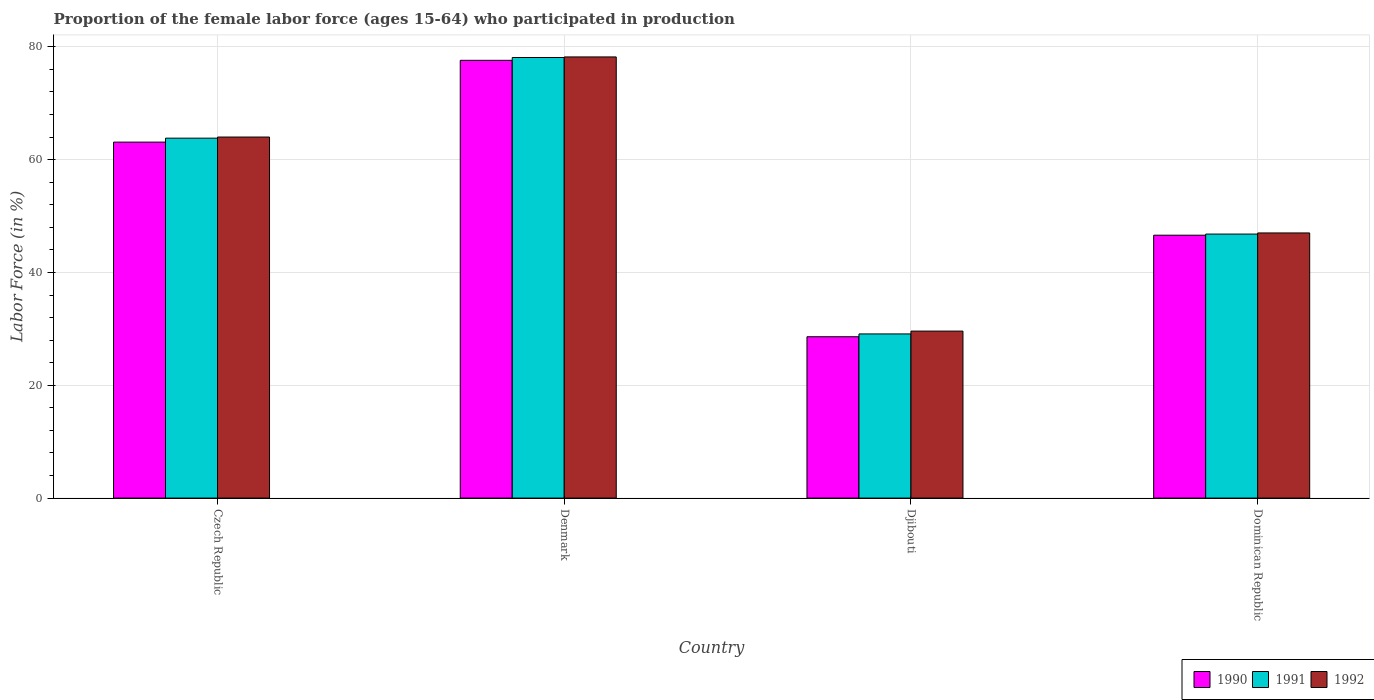How many groups of bars are there?
Keep it short and to the point. 4. How many bars are there on the 4th tick from the right?
Make the answer very short. 3. What is the label of the 4th group of bars from the left?
Provide a succinct answer. Dominican Republic. What is the proportion of the female labor force who participated in production in 1990 in Djibouti?
Provide a short and direct response. 28.6. Across all countries, what is the maximum proportion of the female labor force who participated in production in 1990?
Offer a terse response. 77.6. Across all countries, what is the minimum proportion of the female labor force who participated in production in 1992?
Provide a succinct answer. 29.6. In which country was the proportion of the female labor force who participated in production in 1990 minimum?
Your response must be concise. Djibouti. What is the total proportion of the female labor force who participated in production in 1991 in the graph?
Your answer should be very brief. 217.8. What is the difference between the proportion of the female labor force who participated in production in 1990 in Czech Republic and that in Denmark?
Give a very brief answer. -14.5. What is the difference between the proportion of the female labor force who participated in production in 1991 in Dominican Republic and the proportion of the female labor force who participated in production in 1990 in Czech Republic?
Your answer should be very brief. -16.3. What is the average proportion of the female labor force who participated in production in 1990 per country?
Offer a terse response. 53.97. What is the ratio of the proportion of the female labor force who participated in production in 1991 in Djibouti to that in Dominican Republic?
Keep it short and to the point. 0.62. Is the proportion of the female labor force who participated in production in 1990 in Czech Republic less than that in Denmark?
Your answer should be compact. Yes. What is the difference between the highest and the second highest proportion of the female labor force who participated in production in 1991?
Offer a very short reply. -31.3. What is the difference between the highest and the lowest proportion of the female labor force who participated in production in 1992?
Your answer should be compact. 48.6. What does the 2nd bar from the right in Djibouti represents?
Ensure brevity in your answer.  1991. Is it the case that in every country, the sum of the proportion of the female labor force who participated in production in 1990 and proportion of the female labor force who participated in production in 1992 is greater than the proportion of the female labor force who participated in production in 1991?
Make the answer very short. Yes. How many countries are there in the graph?
Make the answer very short. 4. What is the difference between two consecutive major ticks on the Y-axis?
Your answer should be very brief. 20. Does the graph contain any zero values?
Give a very brief answer. No. Does the graph contain grids?
Give a very brief answer. Yes. How many legend labels are there?
Your answer should be very brief. 3. What is the title of the graph?
Give a very brief answer. Proportion of the female labor force (ages 15-64) who participated in production. Does "1981" appear as one of the legend labels in the graph?
Your answer should be compact. No. What is the Labor Force (in %) in 1990 in Czech Republic?
Your answer should be very brief. 63.1. What is the Labor Force (in %) in 1991 in Czech Republic?
Your answer should be compact. 63.8. What is the Labor Force (in %) of 1992 in Czech Republic?
Your response must be concise. 64. What is the Labor Force (in %) of 1990 in Denmark?
Keep it short and to the point. 77.6. What is the Labor Force (in %) of 1991 in Denmark?
Offer a very short reply. 78.1. What is the Labor Force (in %) in 1992 in Denmark?
Your answer should be compact. 78.2. What is the Labor Force (in %) of 1990 in Djibouti?
Offer a very short reply. 28.6. What is the Labor Force (in %) in 1991 in Djibouti?
Give a very brief answer. 29.1. What is the Labor Force (in %) of 1992 in Djibouti?
Your response must be concise. 29.6. What is the Labor Force (in %) in 1990 in Dominican Republic?
Provide a succinct answer. 46.6. What is the Labor Force (in %) in 1991 in Dominican Republic?
Provide a short and direct response. 46.8. Across all countries, what is the maximum Labor Force (in %) of 1990?
Your answer should be very brief. 77.6. Across all countries, what is the maximum Labor Force (in %) of 1991?
Offer a terse response. 78.1. Across all countries, what is the maximum Labor Force (in %) of 1992?
Offer a terse response. 78.2. Across all countries, what is the minimum Labor Force (in %) of 1990?
Make the answer very short. 28.6. Across all countries, what is the minimum Labor Force (in %) of 1991?
Keep it short and to the point. 29.1. Across all countries, what is the minimum Labor Force (in %) of 1992?
Give a very brief answer. 29.6. What is the total Labor Force (in %) of 1990 in the graph?
Offer a very short reply. 215.9. What is the total Labor Force (in %) of 1991 in the graph?
Your answer should be compact. 217.8. What is the total Labor Force (in %) in 1992 in the graph?
Keep it short and to the point. 218.8. What is the difference between the Labor Force (in %) of 1991 in Czech Republic and that in Denmark?
Provide a succinct answer. -14.3. What is the difference between the Labor Force (in %) in 1990 in Czech Republic and that in Djibouti?
Make the answer very short. 34.5. What is the difference between the Labor Force (in %) of 1991 in Czech Republic and that in Djibouti?
Your response must be concise. 34.7. What is the difference between the Labor Force (in %) of 1992 in Czech Republic and that in Djibouti?
Provide a succinct answer. 34.4. What is the difference between the Labor Force (in %) in 1991 in Denmark and that in Djibouti?
Keep it short and to the point. 49. What is the difference between the Labor Force (in %) in 1992 in Denmark and that in Djibouti?
Your answer should be compact. 48.6. What is the difference between the Labor Force (in %) of 1990 in Denmark and that in Dominican Republic?
Provide a succinct answer. 31. What is the difference between the Labor Force (in %) in 1991 in Denmark and that in Dominican Republic?
Offer a terse response. 31.3. What is the difference between the Labor Force (in %) in 1992 in Denmark and that in Dominican Republic?
Provide a succinct answer. 31.2. What is the difference between the Labor Force (in %) in 1991 in Djibouti and that in Dominican Republic?
Keep it short and to the point. -17.7. What is the difference between the Labor Force (in %) of 1992 in Djibouti and that in Dominican Republic?
Offer a terse response. -17.4. What is the difference between the Labor Force (in %) in 1990 in Czech Republic and the Labor Force (in %) in 1992 in Denmark?
Your answer should be very brief. -15.1. What is the difference between the Labor Force (in %) in 1991 in Czech Republic and the Labor Force (in %) in 1992 in Denmark?
Provide a succinct answer. -14.4. What is the difference between the Labor Force (in %) in 1990 in Czech Republic and the Labor Force (in %) in 1991 in Djibouti?
Your answer should be very brief. 34. What is the difference between the Labor Force (in %) in 1990 in Czech Republic and the Labor Force (in %) in 1992 in Djibouti?
Give a very brief answer. 33.5. What is the difference between the Labor Force (in %) of 1991 in Czech Republic and the Labor Force (in %) of 1992 in Djibouti?
Your answer should be very brief. 34.2. What is the difference between the Labor Force (in %) in 1990 in Czech Republic and the Labor Force (in %) in 1992 in Dominican Republic?
Your answer should be very brief. 16.1. What is the difference between the Labor Force (in %) in 1990 in Denmark and the Labor Force (in %) in 1991 in Djibouti?
Provide a succinct answer. 48.5. What is the difference between the Labor Force (in %) in 1990 in Denmark and the Labor Force (in %) in 1992 in Djibouti?
Offer a terse response. 48. What is the difference between the Labor Force (in %) in 1991 in Denmark and the Labor Force (in %) in 1992 in Djibouti?
Make the answer very short. 48.5. What is the difference between the Labor Force (in %) in 1990 in Denmark and the Labor Force (in %) in 1991 in Dominican Republic?
Your answer should be very brief. 30.8. What is the difference between the Labor Force (in %) of 1990 in Denmark and the Labor Force (in %) of 1992 in Dominican Republic?
Your response must be concise. 30.6. What is the difference between the Labor Force (in %) in 1991 in Denmark and the Labor Force (in %) in 1992 in Dominican Republic?
Make the answer very short. 31.1. What is the difference between the Labor Force (in %) of 1990 in Djibouti and the Labor Force (in %) of 1991 in Dominican Republic?
Give a very brief answer. -18.2. What is the difference between the Labor Force (in %) in 1990 in Djibouti and the Labor Force (in %) in 1992 in Dominican Republic?
Provide a succinct answer. -18.4. What is the difference between the Labor Force (in %) in 1991 in Djibouti and the Labor Force (in %) in 1992 in Dominican Republic?
Offer a terse response. -17.9. What is the average Labor Force (in %) in 1990 per country?
Keep it short and to the point. 53.98. What is the average Labor Force (in %) in 1991 per country?
Offer a terse response. 54.45. What is the average Labor Force (in %) in 1992 per country?
Provide a succinct answer. 54.7. What is the difference between the Labor Force (in %) in 1990 and Labor Force (in %) in 1992 in Czech Republic?
Your answer should be very brief. -0.9. What is the difference between the Labor Force (in %) of 1990 and Labor Force (in %) of 1991 in Denmark?
Your answer should be very brief. -0.5. What is the difference between the Labor Force (in %) in 1990 and Labor Force (in %) in 1991 in Djibouti?
Provide a short and direct response. -0.5. What is the difference between the Labor Force (in %) of 1990 and Labor Force (in %) of 1992 in Djibouti?
Keep it short and to the point. -1. What is the difference between the Labor Force (in %) of 1991 and Labor Force (in %) of 1992 in Djibouti?
Your answer should be compact. -0.5. What is the difference between the Labor Force (in %) in 1990 and Labor Force (in %) in 1991 in Dominican Republic?
Make the answer very short. -0.2. What is the ratio of the Labor Force (in %) of 1990 in Czech Republic to that in Denmark?
Your answer should be compact. 0.81. What is the ratio of the Labor Force (in %) in 1991 in Czech Republic to that in Denmark?
Provide a succinct answer. 0.82. What is the ratio of the Labor Force (in %) in 1992 in Czech Republic to that in Denmark?
Ensure brevity in your answer.  0.82. What is the ratio of the Labor Force (in %) in 1990 in Czech Republic to that in Djibouti?
Keep it short and to the point. 2.21. What is the ratio of the Labor Force (in %) of 1991 in Czech Republic to that in Djibouti?
Make the answer very short. 2.19. What is the ratio of the Labor Force (in %) of 1992 in Czech Republic to that in Djibouti?
Make the answer very short. 2.16. What is the ratio of the Labor Force (in %) in 1990 in Czech Republic to that in Dominican Republic?
Provide a short and direct response. 1.35. What is the ratio of the Labor Force (in %) of 1991 in Czech Republic to that in Dominican Republic?
Provide a succinct answer. 1.36. What is the ratio of the Labor Force (in %) of 1992 in Czech Republic to that in Dominican Republic?
Your answer should be compact. 1.36. What is the ratio of the Labor Force (in %) in 1990 in Denmark to that in Djibouti?
Keep it short and to the point. 2.71. What is the ratio of the Labor Force (in %) in 1991 in Denmark to that in Djibouti?
Keep it short and to the point. 2.68. What is the ratio of the Labor Force (in %) of 1992 in Denmark to that in Djibouti?
Offer a very short reply. 2.64. What is the ratio of the Labor Force (in %) in 1990 in Denmark to that in Dominican Republic?
Your answer should be very brief. 1.67. What is the ratio of the Labor Force (in %) of 1991 in Denmark to that in Dominican Republic?
Make the answer very short. 1.67. What is the ratio of the Labor Force (in %) in 1992 in Denmark to that in Dominican Republic?
Keep it short and to the point. 1.66. What is the ratio of the Labor Force (in %) in 1990 in Djibouti to that in Dominican Republic?
Provide a short and direct response. 0.61. What is the ratio of the Labor Force (in %) in 1991 in Djibouti to that in Dominican Republic?
Provide a succinct answer. 0.62. What is the ratio of the Labor Force (in %) of 1992 in Djibouti to that in Dominican Republic?
Your answer should be compact. 0.63. What is the difference between the highest and the second highest Labor Force (in %) of 1991?
Provide a succinct answer. 14.3. What is the difference between the highest and the lowest Labor Force (in %) in 1990?
Ensure brevity in your answer.  49. What is the difference between the highest and the lowest Labor Force (in %) of 1991?
Ensure brevity in your answer.  49. What is the difference between the highest and the lowest Labor Force (in %) of 1992?
Your answer should be compact. 48.6. 